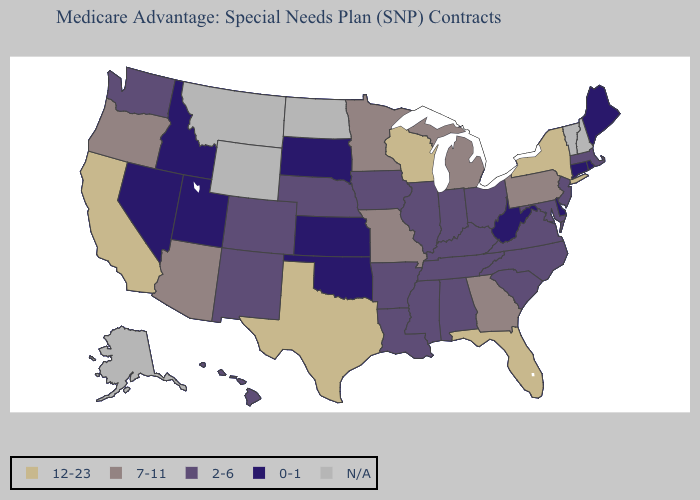What is the highest value in the South ?
Quick response, please. 12-23. Name the states that have a value in the range 12-23?
Give a very brief answer. California, Florida, New York, Texas, Wisconsin. How many symbols are there in the legend?
Give a very brief answer. 5. Name the states that have a value in the range 7-11?
Keep it brief. Arizona, Georgia, Michigan, Minnesota, Missouri, Oregon, Pennsylvania. Which states hav the highest value in the West?
Be succinct. California. Which states have the lowest value in the MidWest?
Write a very short answer. Kansas, South Dakota. Does Idaho have the lowest value in the USA?
Write a very short answer. Yes. What is the highest value in the South ?
Short answer required. 12-23. Does Virginia have the lowest value in the South?
Concise answer only. No. Name the states that have a value in the range 2-6?
Short answer required. Alabama, Arkansas, Colorado, Hawaii, Iowa, Illinois, Indiana, Kentucky, Louisiana, Massachusetts, Maryland, Mississippi, North Carolina, Nebraska, New Jersey, New Mexico, Ohio, South Carolina, Tennessee, Virginia, Washington. Among the states that border New Hampshire , which have the highest value?
Keep it brief. Massachusetts. Name the states that have a value in the range 7-11?
Keep it brief. Arizona, Georgia, Michigan, Minnesota, Missouri, Oregon, Pennsylvania. What is the highest value in the USA?
Keep it brief. 12-23. Among the states that border Massachusetts , which have the lowest value?
Give a very brief answer. Connecticut, Rhode Island. 